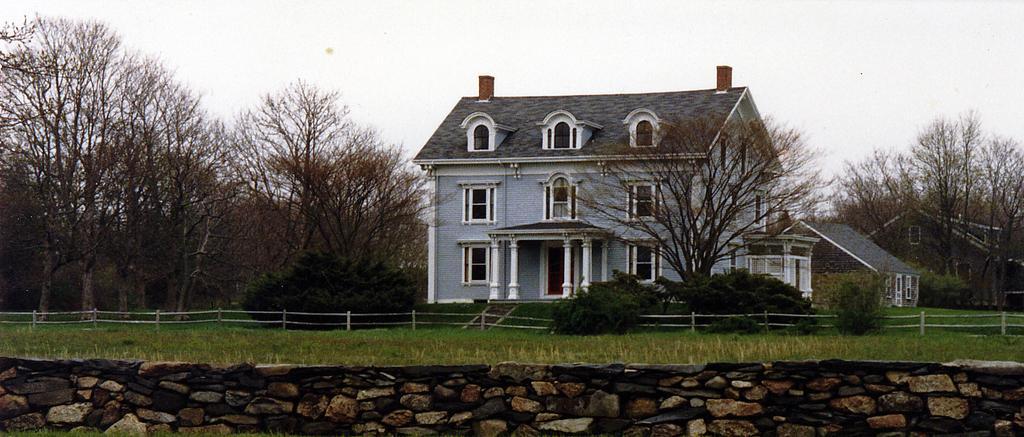How would you summarize this image in a sentence or two? This picture shows a house and we see trees and grass on the ground and we see a cloudy sky. 